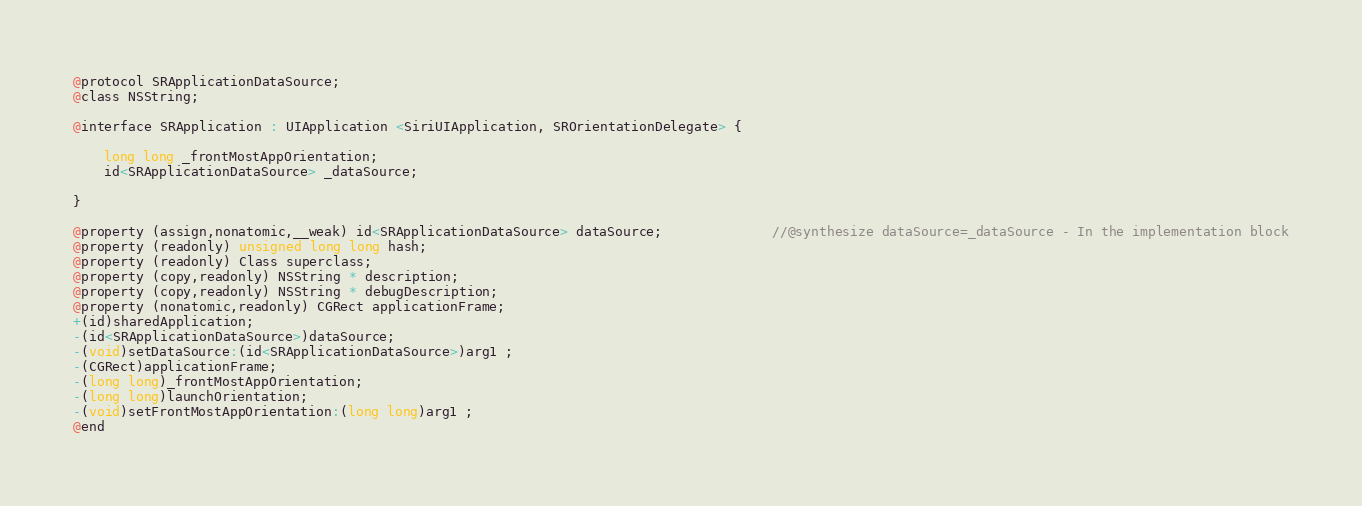Convert code to text. <code><loc_0><loc_0><loc_500><loc_500><_C_>
@protocol SRApplicationDataSource;
@class NSString;

@interface SRApplication : UIApplication <SiriUIApplication, SROrientationDelegate> {

	long long _frontMostAppOrientation;
	id<SRApplicationDataSource> _dataSource;

}

@property (assign,nonatomic,__weak) id<SRApplicationDataSource> dataSource;              //@synthesize dataSource=_dataSource - In the implementation block
@property (readonly) unsigned long long hash; 
@property (readonly) Class superclass; 
@property (copy,readonly) NSString * description; 
@property (copy,readonly) NSString * debugDescription; 
@property (nonatomic,readonly) CGRect applicationFrame; 
+(id)sharedApplication;
-(id<SRApplicationDataSource>)dataSource;
-(void)setDataSource:(id<SRApplicationDataSource>)arg1 ;
-(CGRect)applicationFrame;
-(long long)_frontMostAppOrientation;
-(long long)launchOrientation;
-(void)setFrontMostAppOrientation:(long long)arg1 ;
@end

</code> 